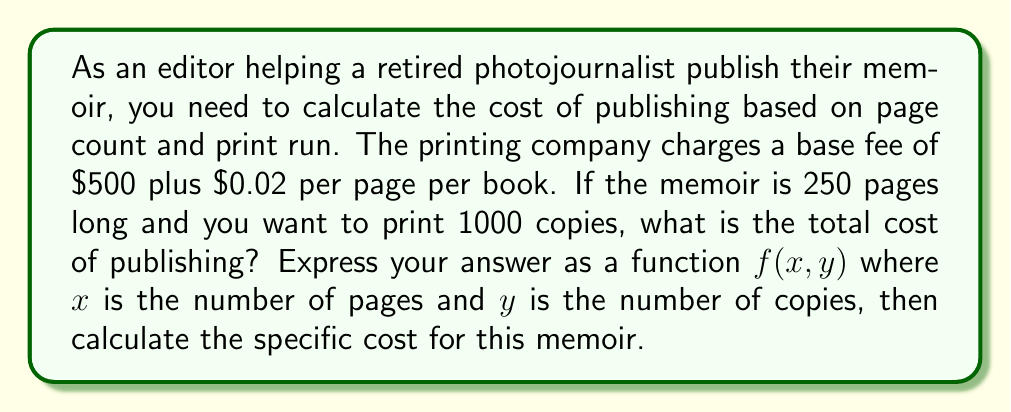Can you solve this math problem? To solve this problem, we need to create a function that calculates the total cost based on the number of pages and the number of copies. Let's break it down step by step:

1. Define the function:
   $f(x,y)$ = base fee + (cost per page × number of pages × number of copies)
   
2. Substitute the given values:
   Base fee = $500
   Cost per page = $0.02
   
3. Express the function mathematically:
   $$f(x,y) = 500 + 0.02xy$$

   Where $x$ is the number of pages and $y$ is the number of copies.

4. For this specific memoir:
   $x = 250$ (pages)
   $y = 1000$ (copies)

5. Calculate the total cost:
   $$f(250, 1000) = 500 + 0.02(250)(1000)$$
   $$= 500 + 0.02(250000)$$
   $$= 500 + 5000$$
   $$= 5500$$

Therefore, the total cost of publishing the memoir is $5,500.
Answer: The function for calculating the cost is $f(x,y) = 500 + 0.02xy$, and the total cost for publishing the 250-page memoir with a print run of 1000 copies is $5,500. 